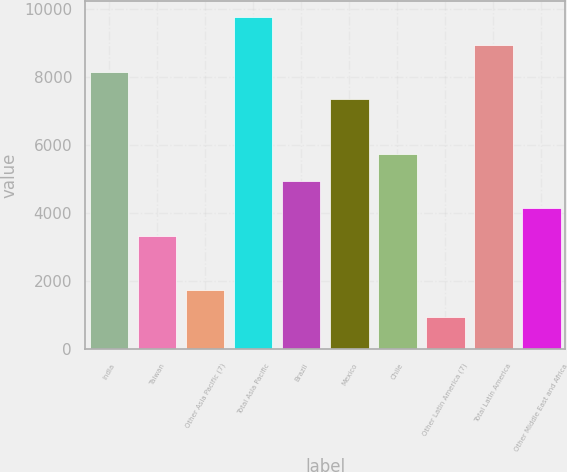Convert chart. <chart><loc_0><loc_0><loc_500><loc_500><bar_chart><fcel>India<fcel>Taiwan<fcel>Other Asia Pacific (7)<fcel>Total Asia Pacific<fcel>Brazil<fcel>Mexico<fcel>Chile<fcel>Other Latin America (7)<fcel>Total Latin America<fcel>Other Middle East and Africa<nl><fcel>8149<fcel>3344.2<fcel>1742.6<fcel>9750.6<fcel>4945.8<fcel>7348.2<fcel>5746.6<fcel>941.8<fcel>8949.8<fcel>4145<nl></chart> 